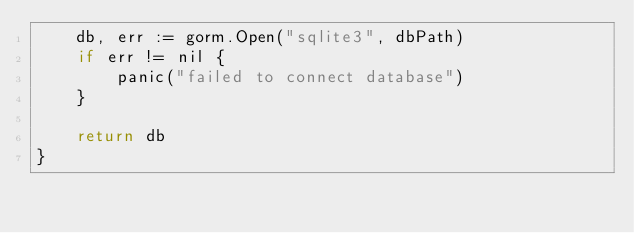<code> <loc_0><loc_0><loc_500><loc_500><_Go_>	db, err := gorm.Open("sqlite3", dbPath)
	if err != nil {
		panic("failed to connect database")
	}

	return db
}
</code> 